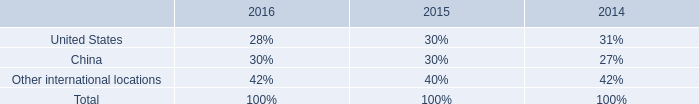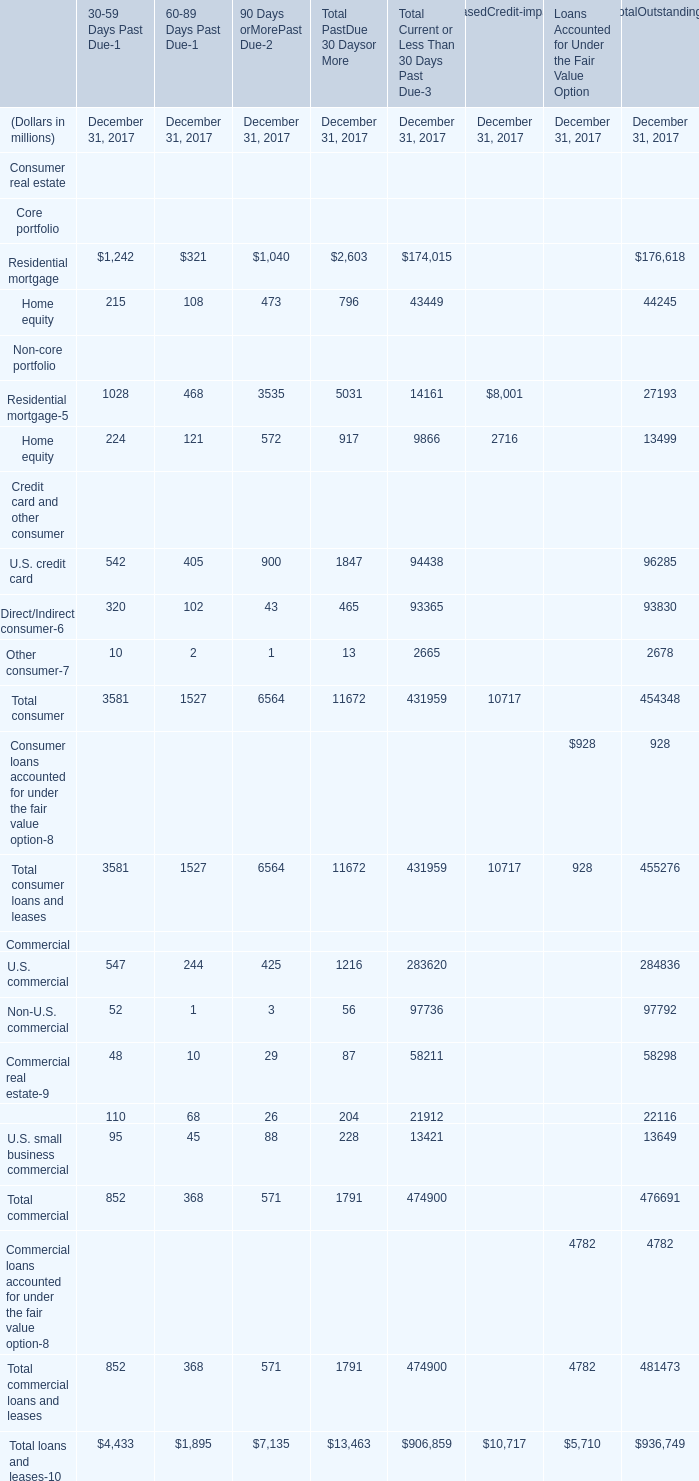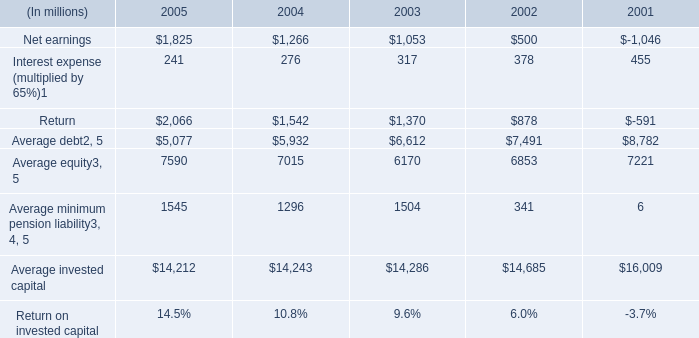what was the percent of the change in the net earnings from 2004 to 2005 
Computations: ((1825 - 1266) / 1266)
Answer: 0.44155. 